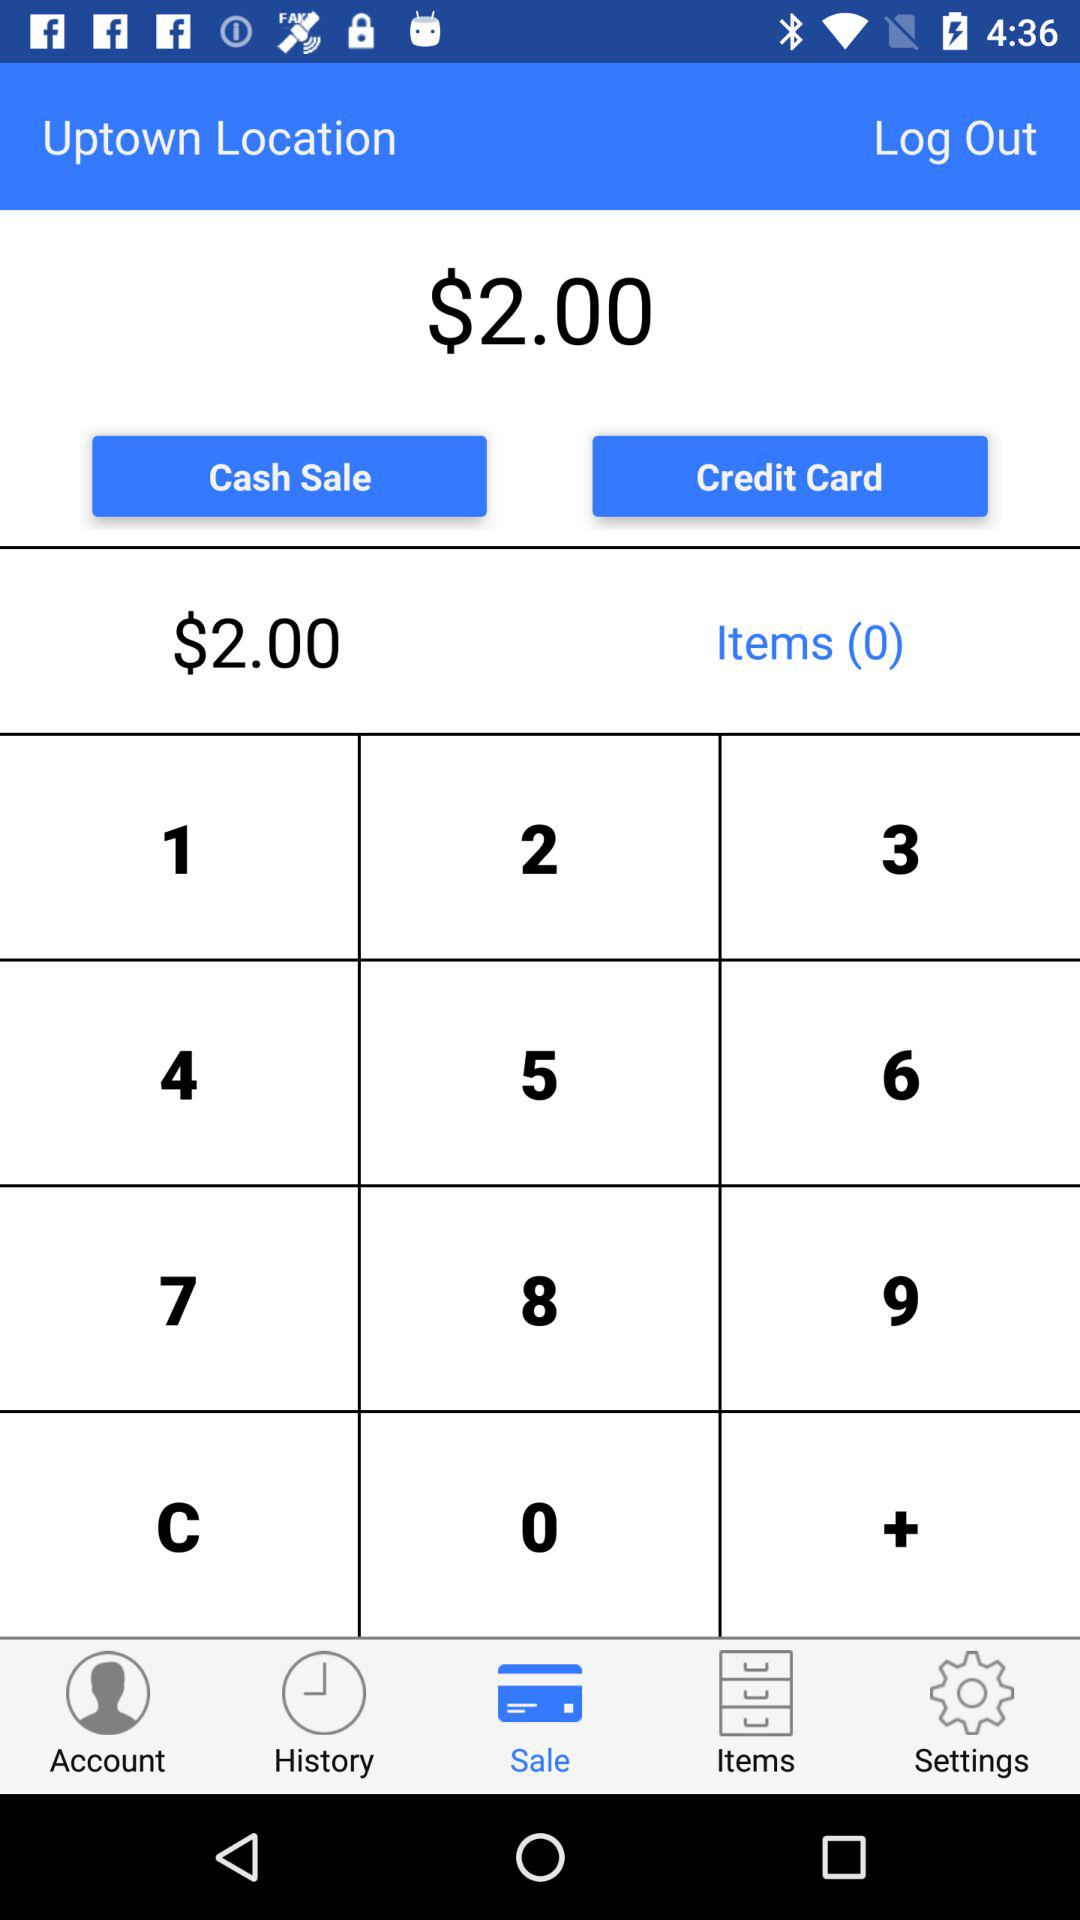How many items are there? There are 0 items. 